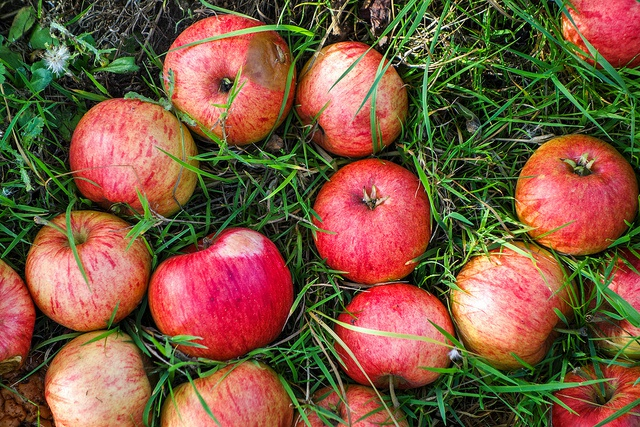Describe the objects in this image and their specific colors. I can see apple in black, maroon, brown, and darkgreen tones, apple in black, brown, and salmon tones, apple in black, salmon, lightpink, and brown tones, apple in black, salmon, red, and brown tones, and apple in black, salmon, and brown tones in this image. 